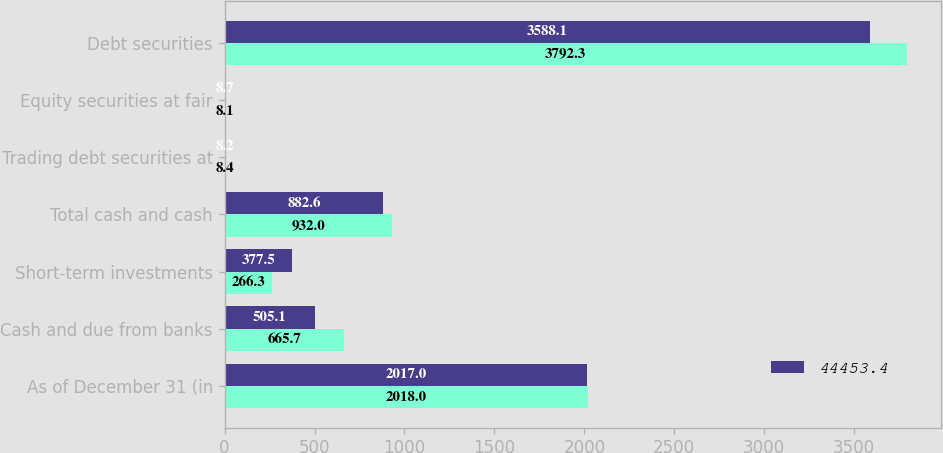Convert chart to OTSL. <chart><loc_0><loc_0><loc_500><loc_500><stacked_bar_chart><ecel><fcel>As of December 31 (in<fcel>Cash and due from banks<fcel>Short-term investments<fcel>Total cash and cash<fcel>Trading debt securities at<fcel>Equity securities at fair<fcel>Debt securities<nl><fcel>nan<fcel>2018<fcel>665.7<fcel>266.3<fcel>932<fcel>8.4<fcel>8.1<fcel>3792.3<nl><fcel>44453.4<fcel>2017<fcel>505.1<fcel>377.5<fcel>882.6<fcel>8.2<fcel>8.7<fcel>3588.1<nl></chart> 